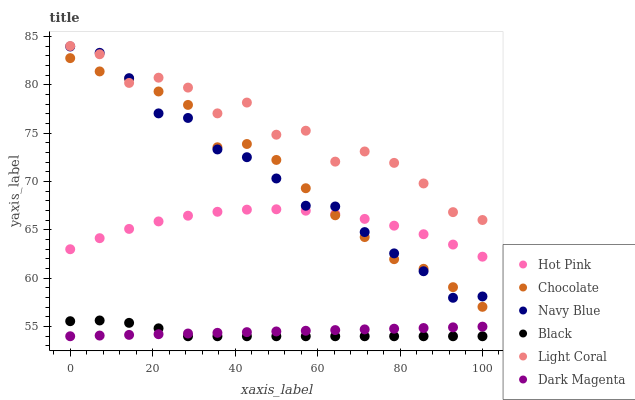Does Black have the minimum area under the curve?
Answer yes or no. Yes. Does Light Coral have the maximum area under the curve?
Answer yes or no. Yes. Does Navy Blue have the minimum area under the curve?
Answer yes or no. No. Does Navy Blue have the maximum area under the curve?
Answer yes or no. No. Is Dark Magenta the smoothest?
Answer yes or no. Yes. Is Light Coral the roughest?
Answer yes or no. Yes. Is Navy Blue the smoothest?
Answer yes or no. No. Is Navy Blue the roughest?
Answer yes or no. No. Does Dark Magenta have the lowest value?
Answer yes or no. Yes. Does Navy Blue have the lowest value?
Answer yes or no. No. Does Light Coral have the highest value?
Answer yes or no. Yes. Does Navy Blue have the highest value?
Answer yes or no. No. Is Dark Magenta less than Hot Pink?
Answer yes or no. Yes. Is Chocolate greater than Dark Magenta?
Answer yes or no. Yes. Does Chocolate intersect Light Coral?
Answer yes or no. Yes. Is Chocolate less than Light Coral?
Answer yes or no. No. Is Chocolate greater than Light Coral?
Answer yes or no. No. Does Dark Magenta intersect Hot Pink?
Answer yes or no. No. 